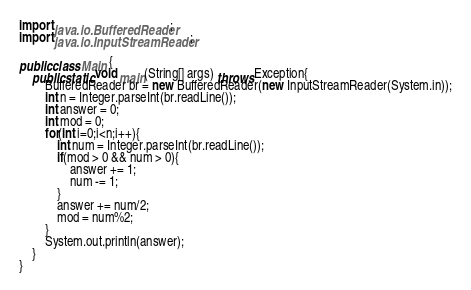<code> <loc_0><loc_0><loc_500><loc_500><_Java_>import java.io.BufferedReader;
import java.io.InputStreamReader;

public class Main {
	public static void main(String[] args) throws Exception{
		BufferedReader br = new BufferedReader(new InputStreamReader(System.in));
		int n = Integer.parseInt(br.readLine());
		int answer = 0;
		int mod = 0;
		for(int i=0;i<n;i++){
			int num = Integer.parseInt(br.readLine());
			if(mod > 0 && num > 0){
				answer += 1;
				num -= 1;
			}
			answer += num/2;
			mod = num%2;
		}
		System.out.println(answer);
	}
}
</code> 